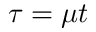<formula> <loc_0><loc_0><loc_500><loc_500>\tau = \mu t</formula> 